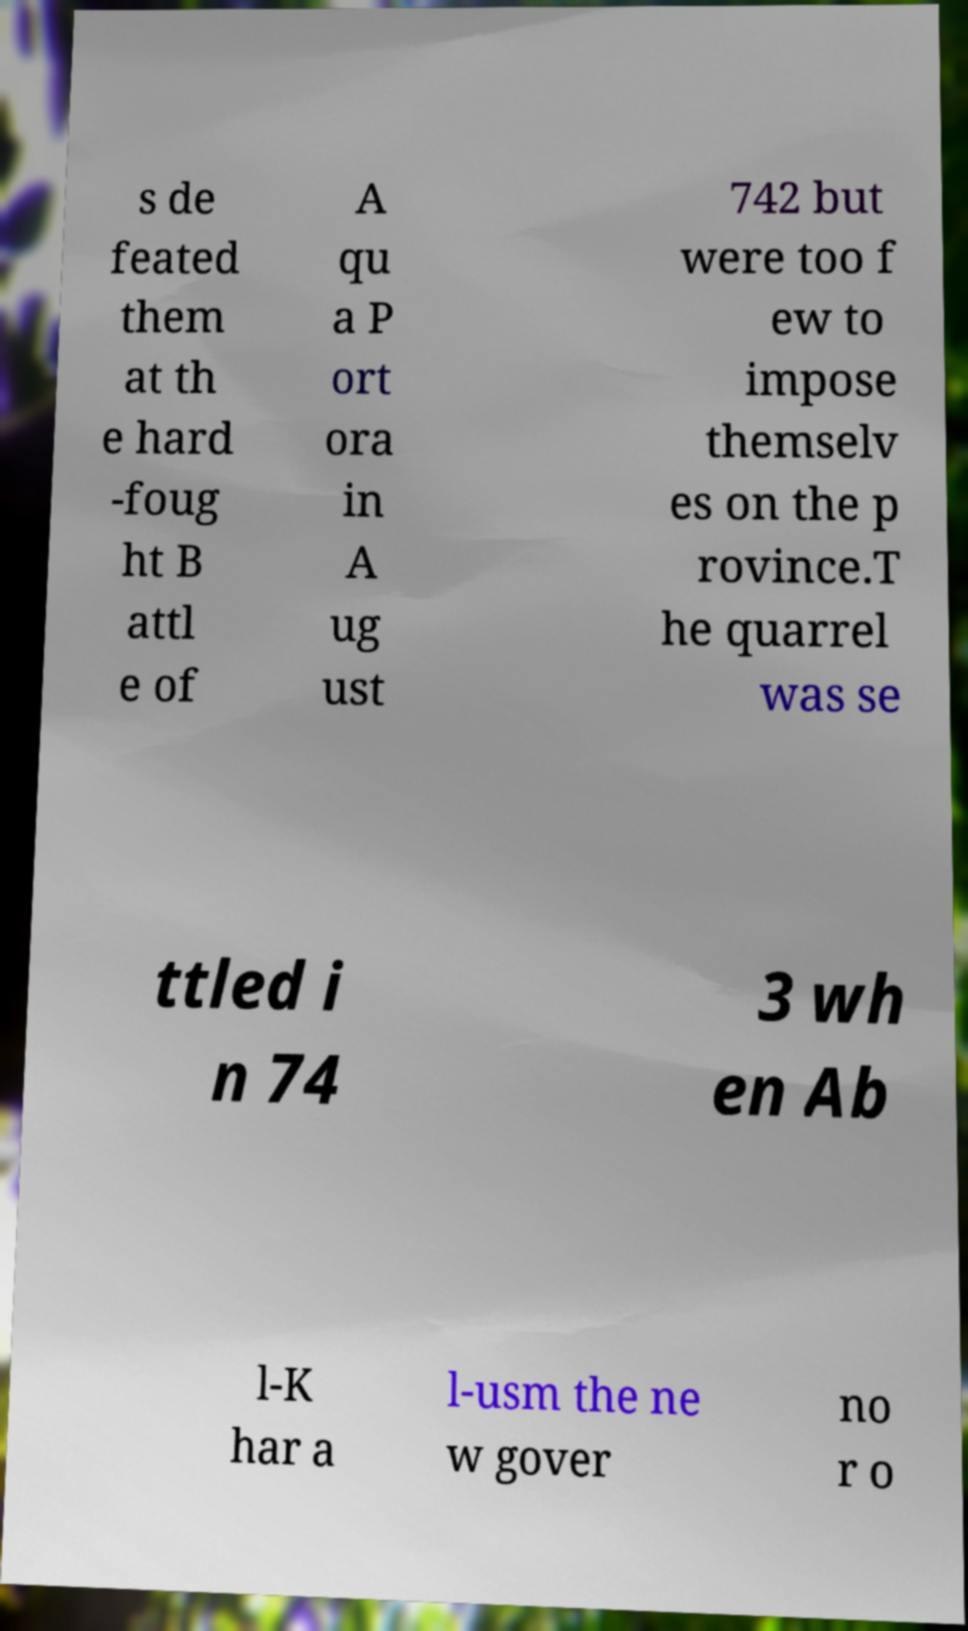Please read and relay the text visible in this image. What does it say? s de feated them at th e hard -foug ht B attl e of A qu a P ort ora in A ug ust 742 but were too f ew to impose themselv es on the p rovince.T he quarrel was se ttled i n 74 3 wh en Ab l-K har a l-usm the ne w gover no r o 